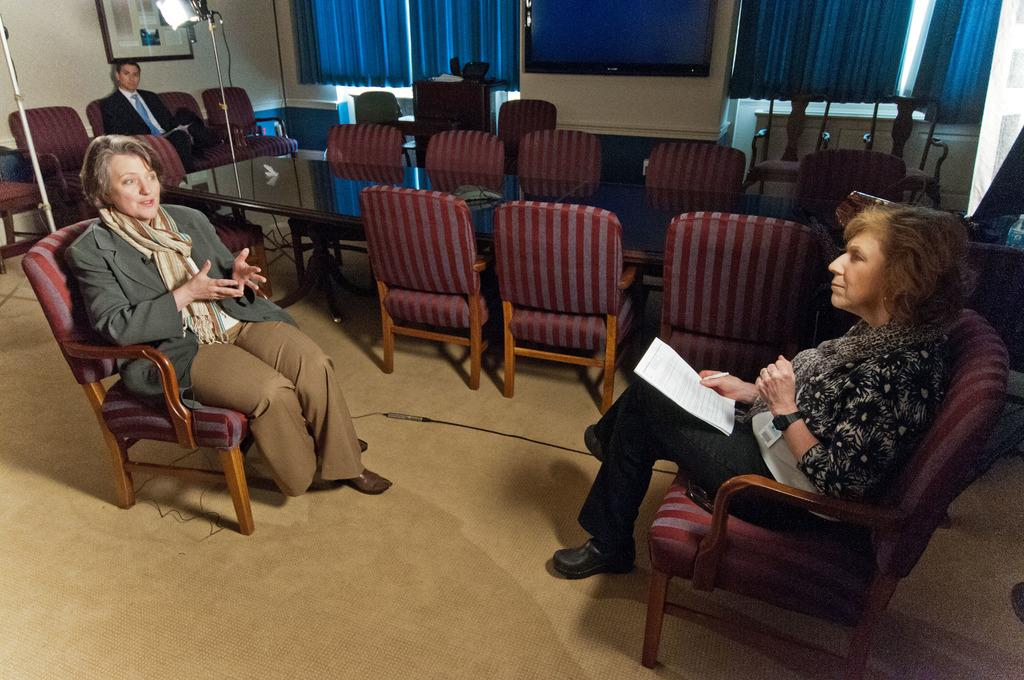How many women are in the image? There are two women in the image. What are the women doing in the image? The women are sitting opposite each other and looking at each other. What type of furniture is present in the image? There are tables and chairs in the image. Can you describe the position of the person behind the women? There is a person sitting behind the women. What type of bird is perched on the crown of the woman on the left? There is no bird or crown present in the image; the women are simply looking at each other while sitting opposite each other. 